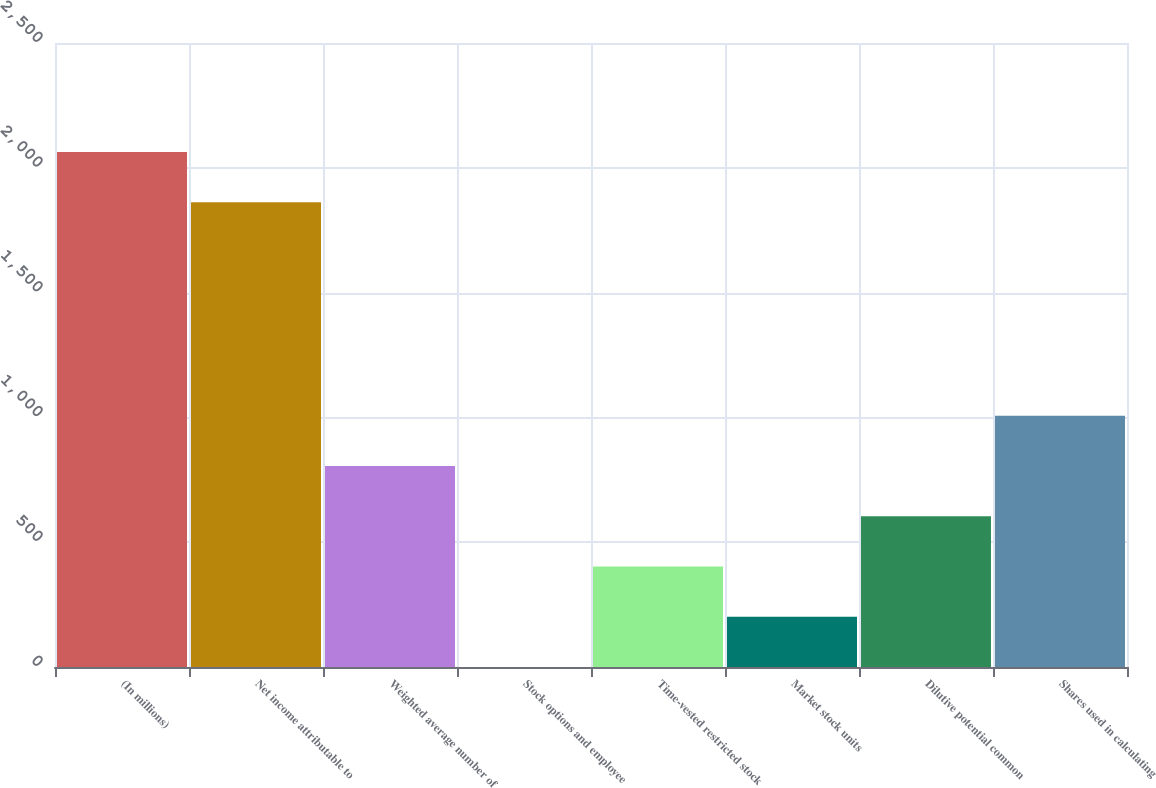Convert chart. <chart><loc_0><loc_0><loc_500><loc_500><bar_chart><fcel>(In millions)<fcel>Net income attributable to<fcel>Weighted average number of<fcel>Stock options and employee<fcel>Time-vested restricted stock<fcel>Market stock units<fcel>Dilutive potential common<fcel>Shares used in calculating<nl><fcel>2063.57<fcel>1862.3<fcel>805.38<fcel>0.3<fcel>402.84<fcel>201.57<fcel>604.11<fcel>1006.65<nl></chart> 